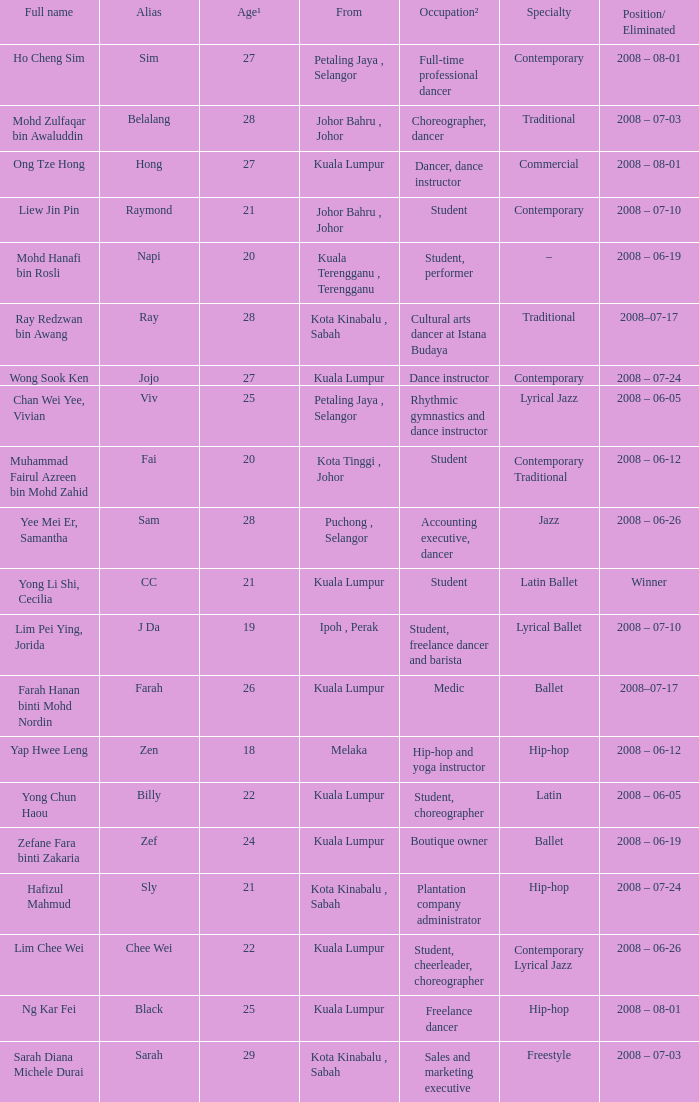What is Occupation², when Age¹ is greater than 24, when Alias is "Black"? Freelance dancer. 